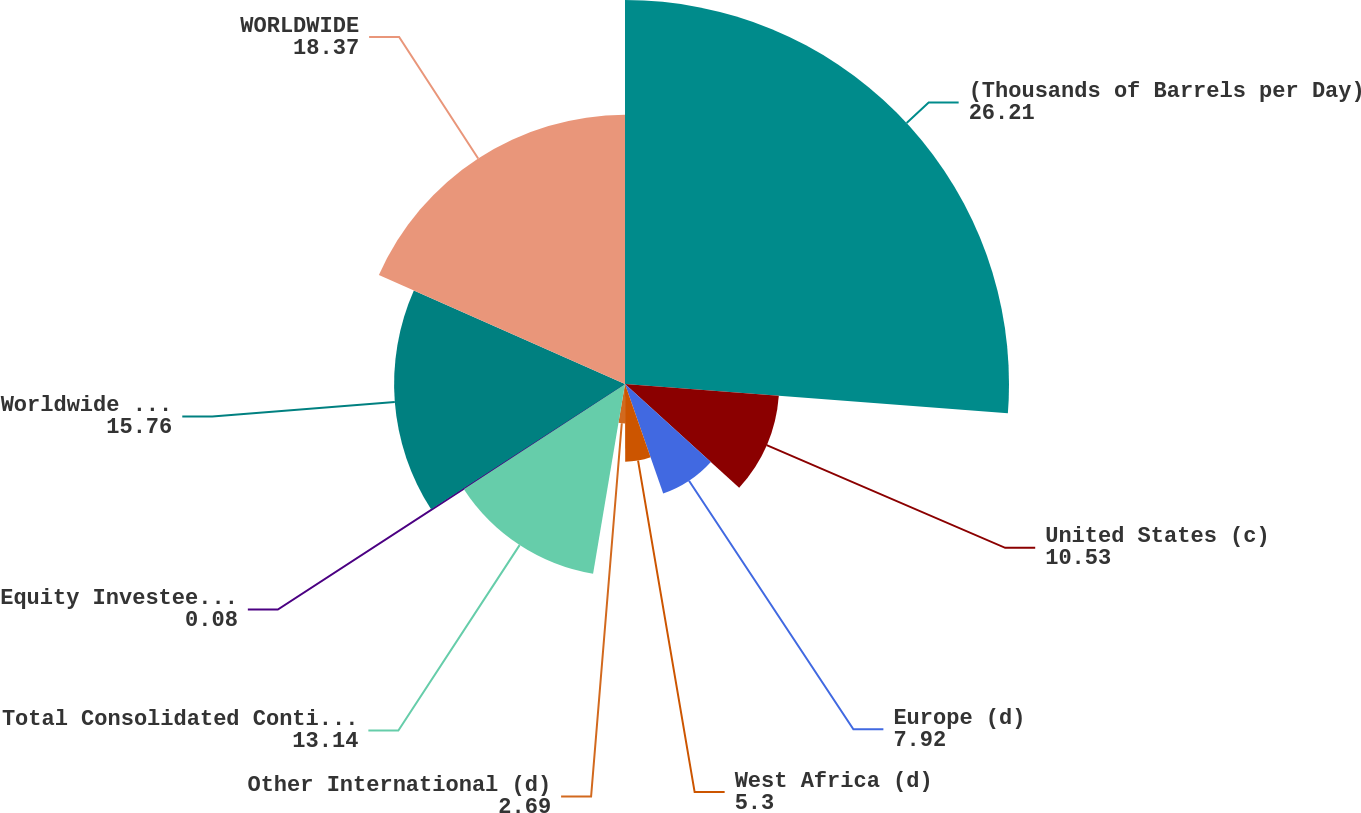Convert chart to OTSL. <chart><loc_0><loc_0><loc_500><loc_500><pie_chart><fcel>(Thousands of Barrels per Day)<fcel>United States (c)<fcel>Europe (d)<fcel>West Africa (d)<fcel>Other International (d)<fcel>Total Consolidated Continuing<fcel>Equity Investees (d)(e)<fcel>Worldwide Continuing<fcel>WORLDWIDE<nl><fcel>26.21%<fcel>10.53%<fcel>7.92%<fcel>5.3%<fcel>2.69%<fcel>13.14%<fcel>0.08%<fcel>15.76%<fcel>18.37%<nl></chart> 